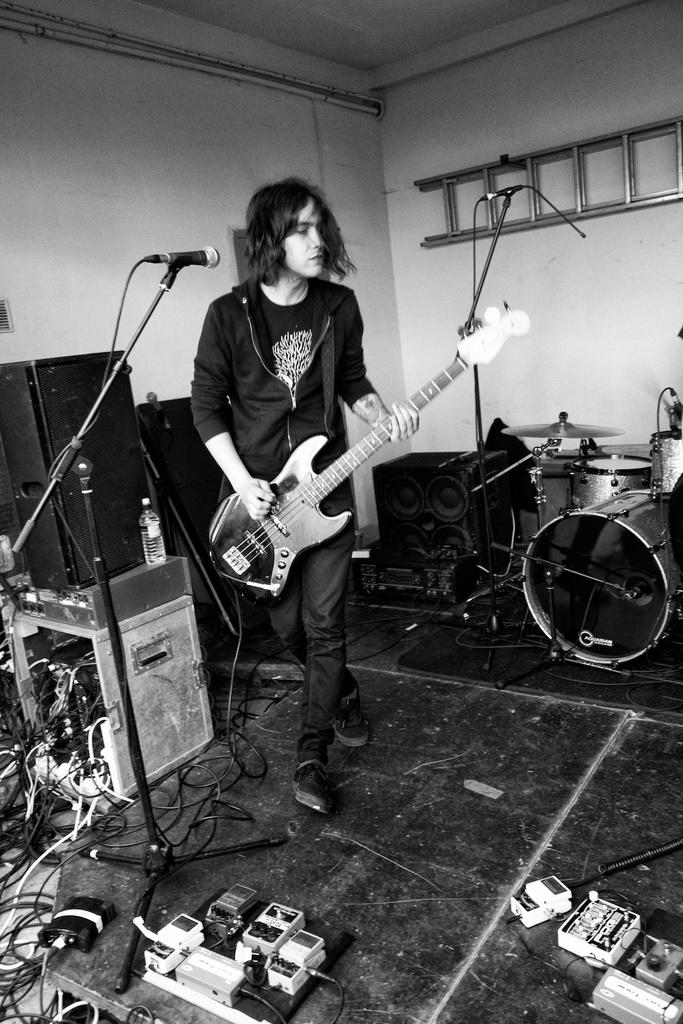What is the person in the image doing? The person is playing a guitar. What is the person wearing in the image? The person is wearing a black dress. What object is in front of the person? There is a microphone in front of the person. What other musical instruments are visible in the image? There are musical instruments around the person. What invention is being tested in the image? There is no invention being tested in the image. 